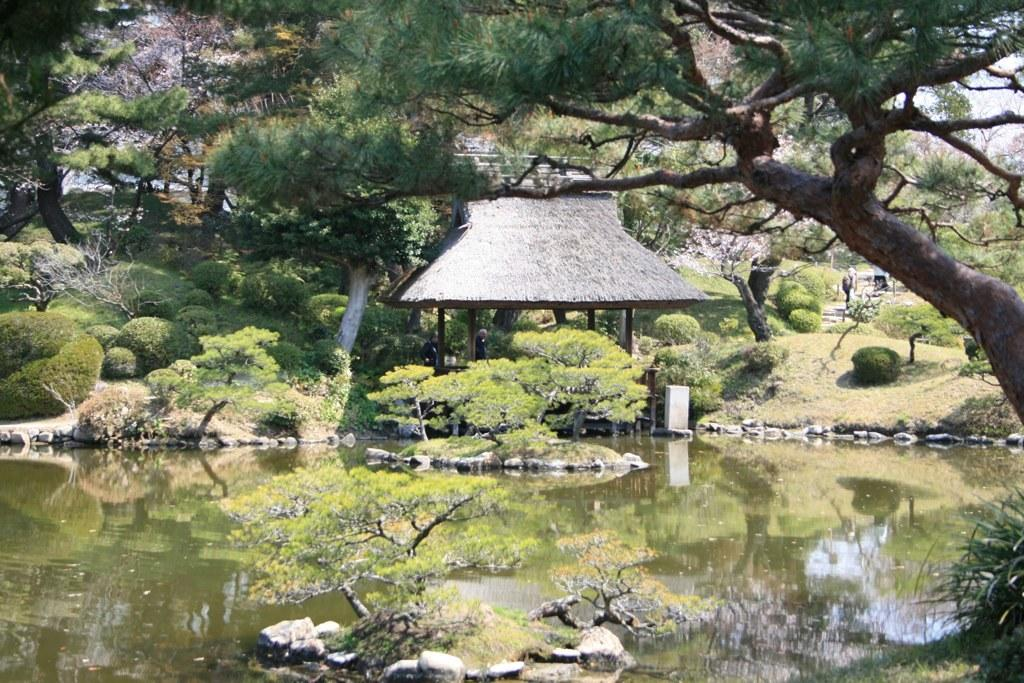What type of structure is in the image? There is a shed in the image. What natural element can be seen in the image? There is water visible in the image. What type of vegetation is present in the image? There are plants in the image. What type of natural scenery is visible in the image? Surrounding trees are present in the image. Can you see a gun being used in the image? No, there is no gun present in the image. What is the thumb doing in the image? There is no thumb visible in the image. 